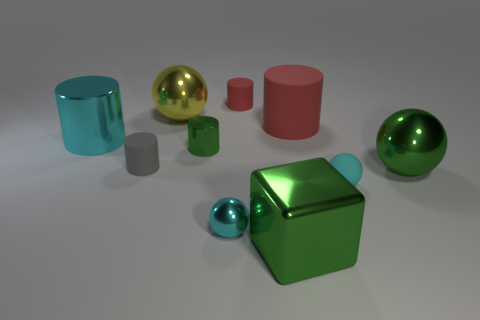Can you describe the texture of the objects on the right side of the image? The objects on the right side of the image have different textures. The sphere and the cylinder appear to have a smooth and glossy finish, while the smaller cube and cylinder seem to have a more matte and slightly rough texture. 